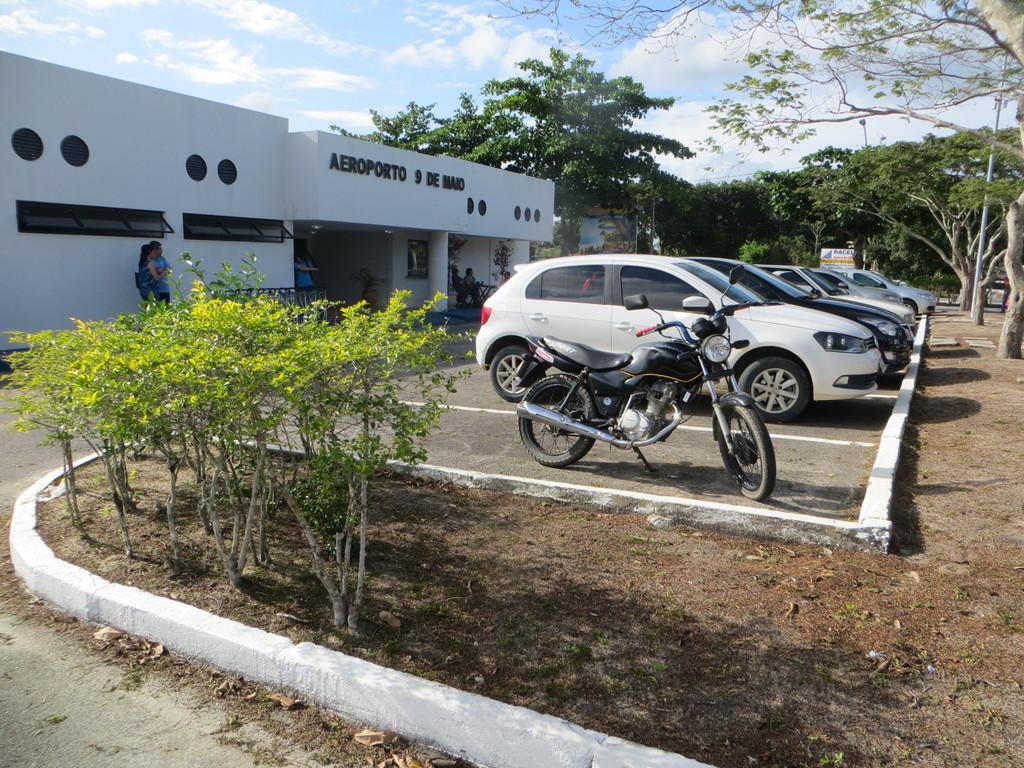Please provide a concise description of this image. On the left side there are some trees. Also there is a small side wall. Some cars and a motorcycle is parked on the parking area. Also there is a building with ventilation, pillar and something is written on that. There are trees. In the background there is sky with clouds. 